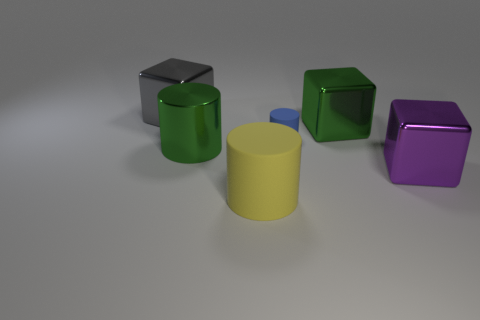The small cylinder has what color?
Your answer should be very brief. Blue. There is a blue object; are there any big purple blocks in front of it?
Ensure brevity in your answer.  Yes. Is the color of the large metal cylinder the same as the small cylinder?
Keep it short and to the point. No. How many other big cylinders have the same color as the large shiny cylinder?
Your answer should be very brief. 0. There is a matte thing behind the metallic object on the right side of the big green cube; how big is it?
Offer a very short reply. Small. The big yellow thing has what shape?
Make the answer very short. Cylinder. There is a green thing that is left of the large rubber thing; what material is it?
Your answer should be very brief. Metal. What is the color of the rubber object that is behind the metal cube right of the green object behind the small cylinder?
Ensure brevity in your answer.  Blue. There is a matte object that is the same size as the purple metal object; what is its color?
Your response must be concise. Yellow. What number of rubber things are small red blocks or gray objects?
Provide a short and direct response. 0. 